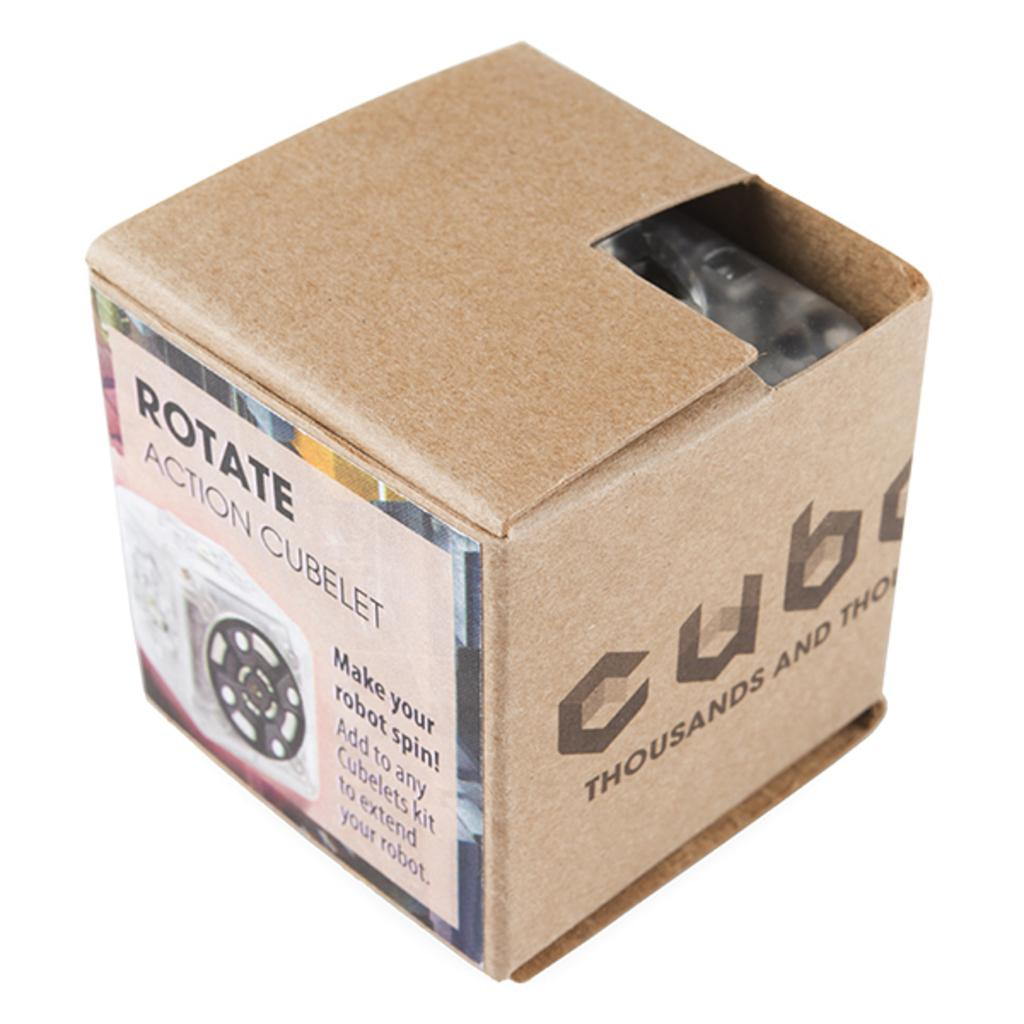<image>
Present a compact description of the photo's key features. Square box with the words Rotate Action Cubelet on it. 